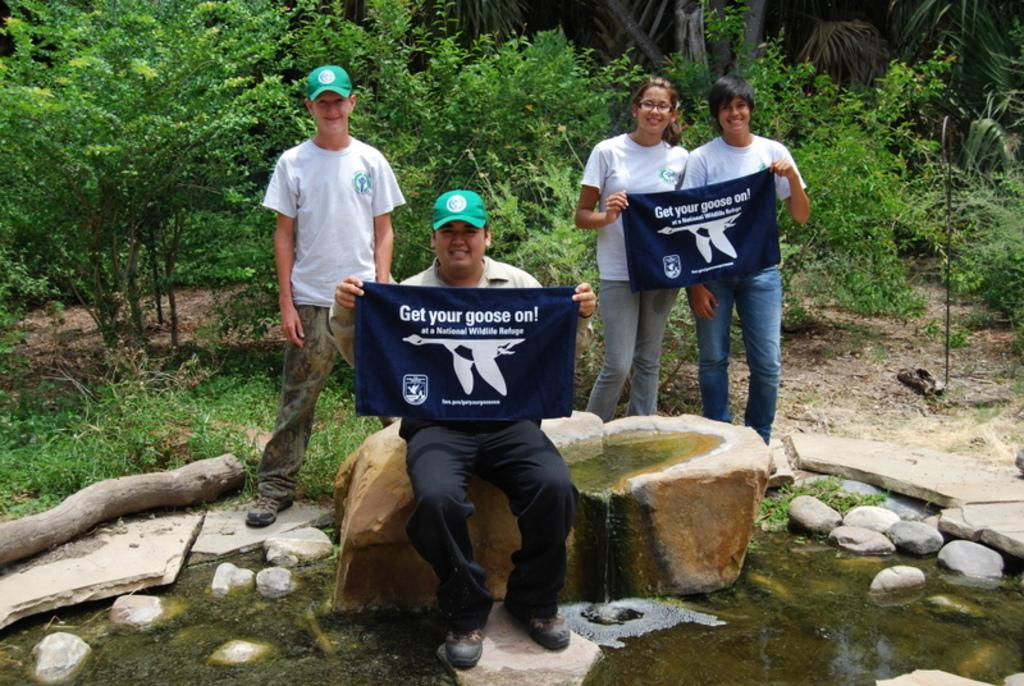<image>
Render a clear and concise summary of the photo. people holding banners that say 'get your goose on' 